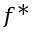<formula> <loc_0><loc_0><loc_500><loc_500>f ^ { * }</formula> 